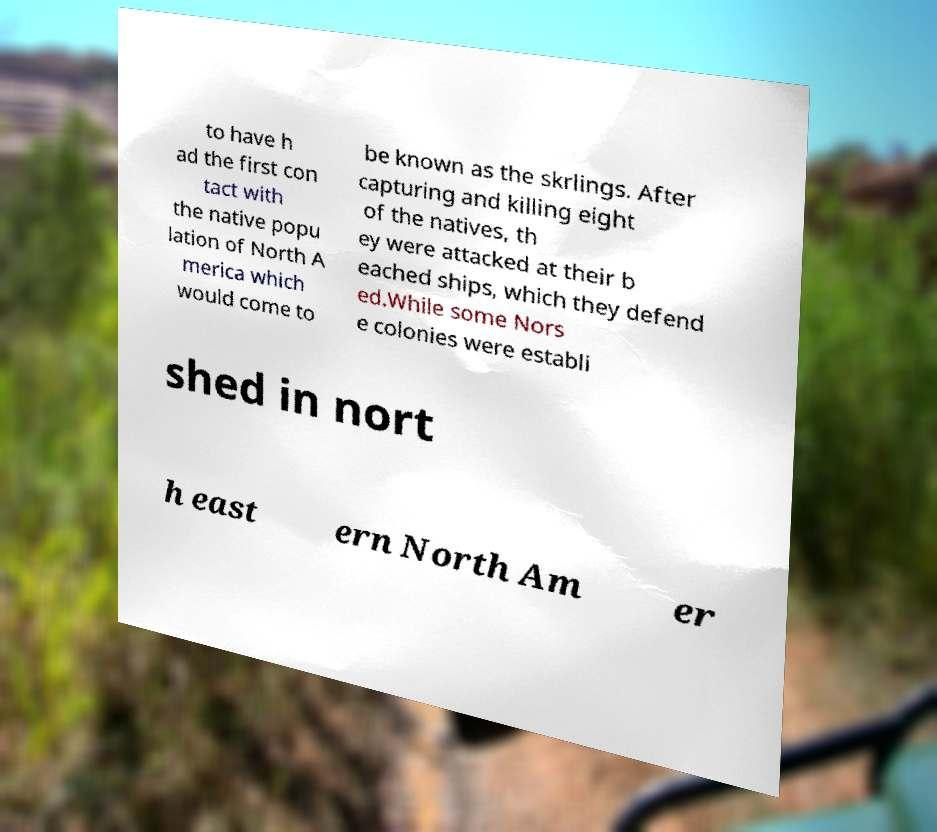I need the written content from this picture converted into text. Can you do that? to have h ad the first con tact with the native popu lation of North A merica which would come to be known as the skrlings. After capturing and killing eight of the natives, th ey were attacked at their b eached ships, which they defend ed.While some Nors e colonies were establi shed in nort h east ern North Am er 